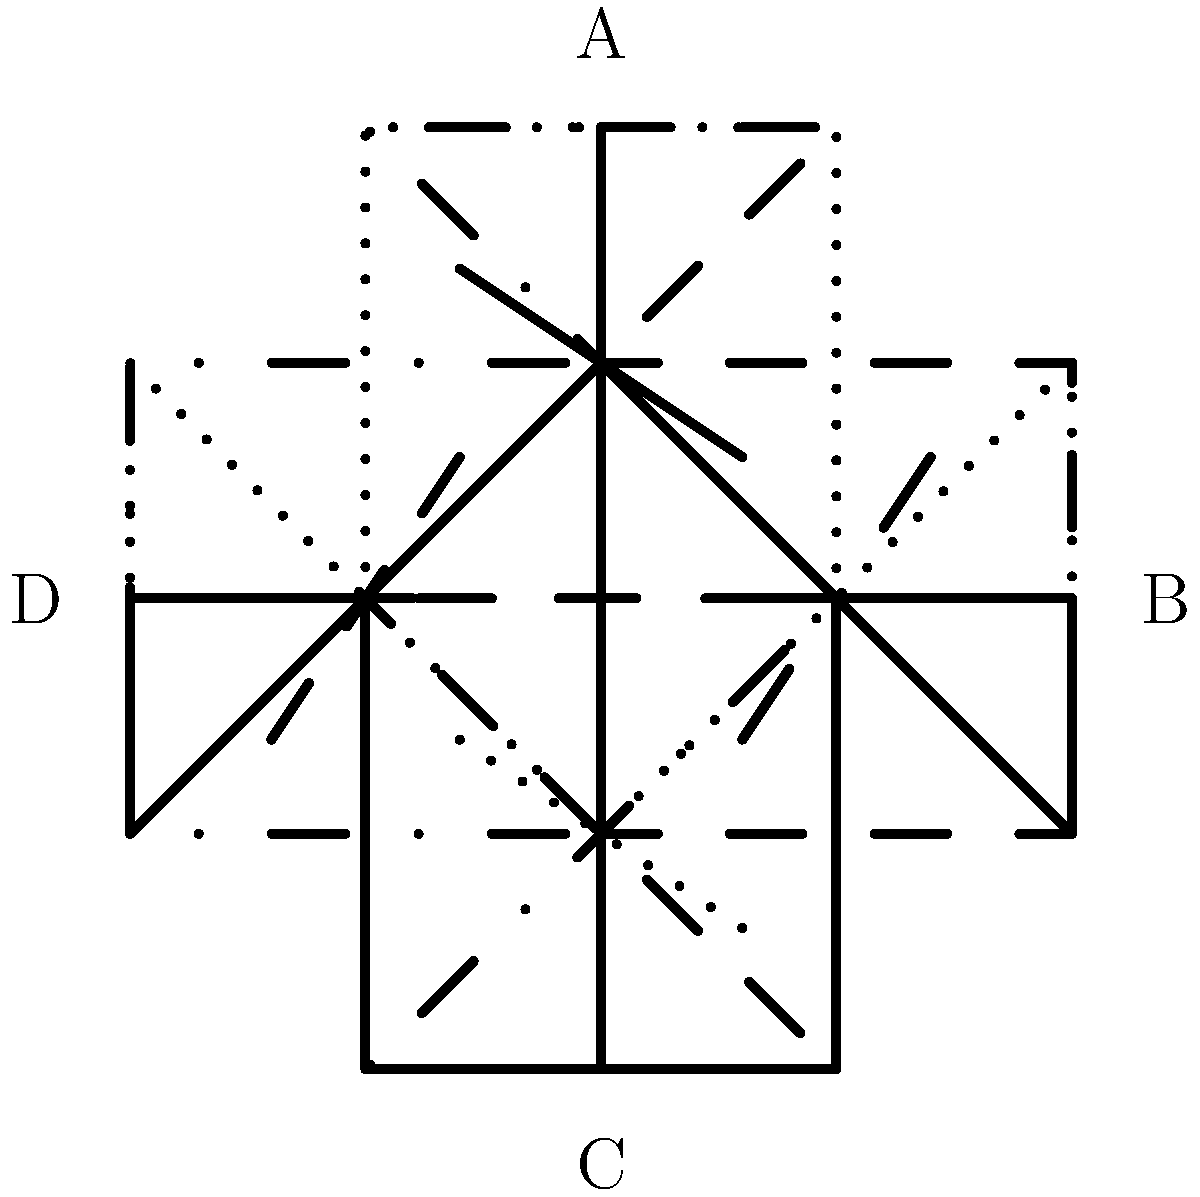Which rotation of the Russian Orthodox cross shown in the solid line is correct according to traditional orientation? To determine the correct orientation of the Russian Orthodox cross, follow these steps:

1. Identify the parts of the cross:
   - The longer vertical beam
   - The shorter horizontal beam
   - The slanted footrest at the bottom

2. Understand the symbolism:
   - The top beam represents the inscription "INRI" (Jesus of Nazareth, King of the Jews)
   - The main horizontal beam is where Christ's hands were nailed
   - The slanted beam represents the footrest

3. Correct orientation:
   - The longer part of the vertical beam should point upwards
   - The slanted footrest should have its right side (from the viewer's perspective) pointing upwards

4. Analyze the given options:
   - Solid line: Correct orientation
   - Dashed line (90° rotation): Incorrect, horizontal
   - Dotted line (180° rotation): Incorrect, upside down
   - Dash-dotted line (270° rotation): Incorrect, horizontal and reversed

5. Conclusion:
   The solid line representation shows the correct orientation, with the longer part of the vertical beam pointing upwards and the slanted footrest's right side pointing upwards.
Answer: Solid line (original orientation) 